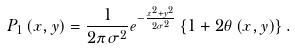<formula> <loc_0><loc_0><loc_500><loc_500>P _ { 1 } \left ( x , y \right ) = \frac { 1 } { 2 \pi \sigma ^ { 2 } } e ^ { - \frac { x ^ { 2 } + y ^ { 2 } } { 2 \sigma ^ { 2 } } } \left \{ 1 + 2 \theta \left ( x , y \right ) \right \} .</formula> 